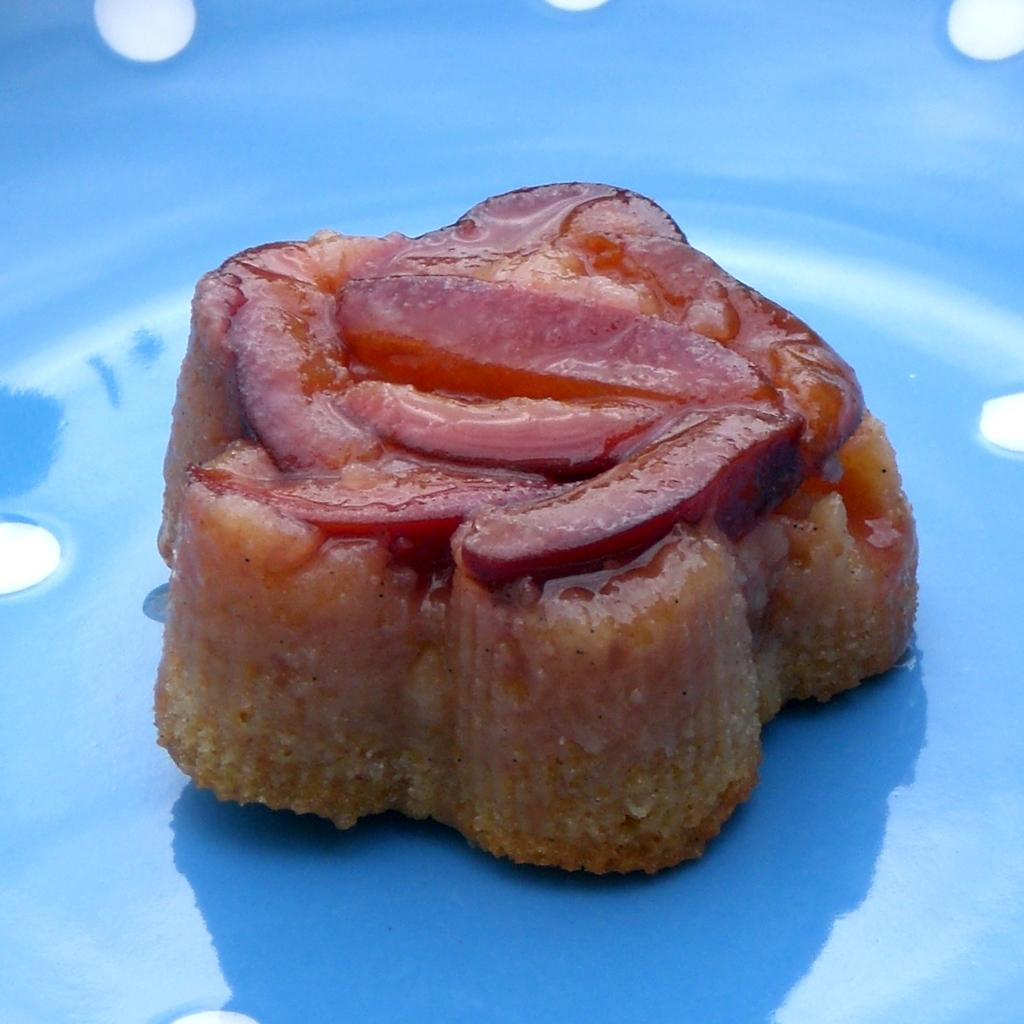What is present on the plate in the image? There is food on the plate in the image. Are there any additional features on the plate? Yes, there are dots on the plate. Where is the stove located in the image? There is no stove present in the image. What type of faucet can be seen in the image? There is no faucet present in the image. 